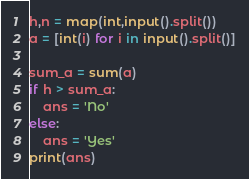<code> <loc_0><loc_0><loc_500><loc_500><_Python_>h,n = map(int,input().split())
a = [int(i) for i in input().split()]

sum_a = sum(a)
if h > sum_a:
    ans = 'No'
else:
    ans = 'Yes'
print(ans)</code> 